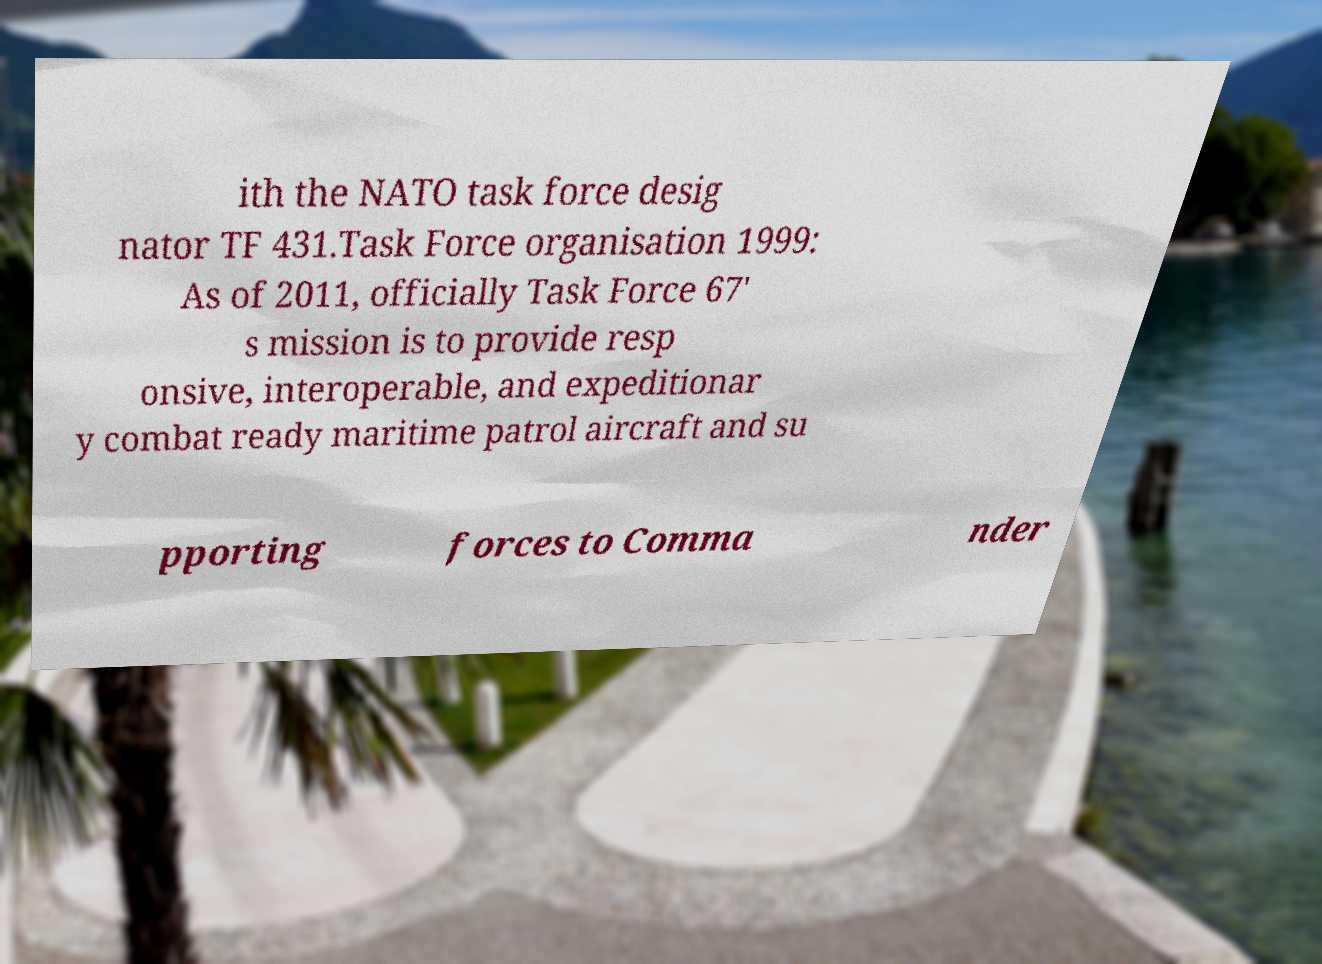Can you accurately transcribe the text from the provided image for me? ith the NATO task force desig nator TF 431.Task Force organisation 1999: As of 2011, officially Task Force 67' s mission is to provide resp onsive, interoperable, and expeditionar y combat ready maritime patrol aircraft and su pporting forces to Comma nder 